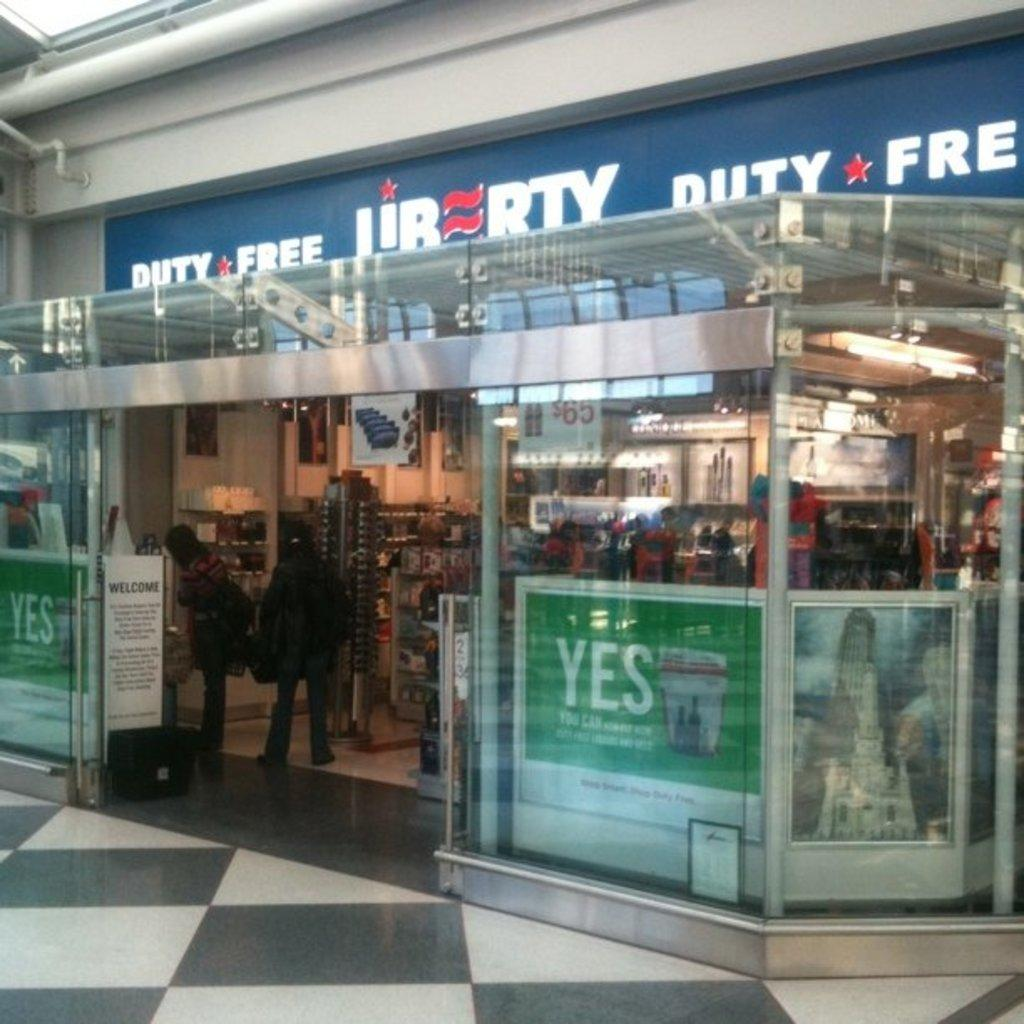<image>
Relay a brief, clear account of the picture shown. The outside of the Liberty Duty Free store with people at the checkout. 